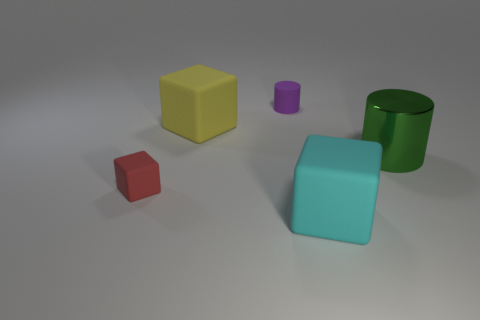Add 1 small objects. How many objects exist? 6 Subtract all cubes. How many objects are left? 2 Add 2 large objects. How many large objects exist? 5 Subtract 1 red blocks. How many objects are left? 4 Subtract all matte cubes. Subtract all tiny gray rubber cylinders. How many objects are left? 2 Add 1 large cylinders. How many large cylinders are left? 2 